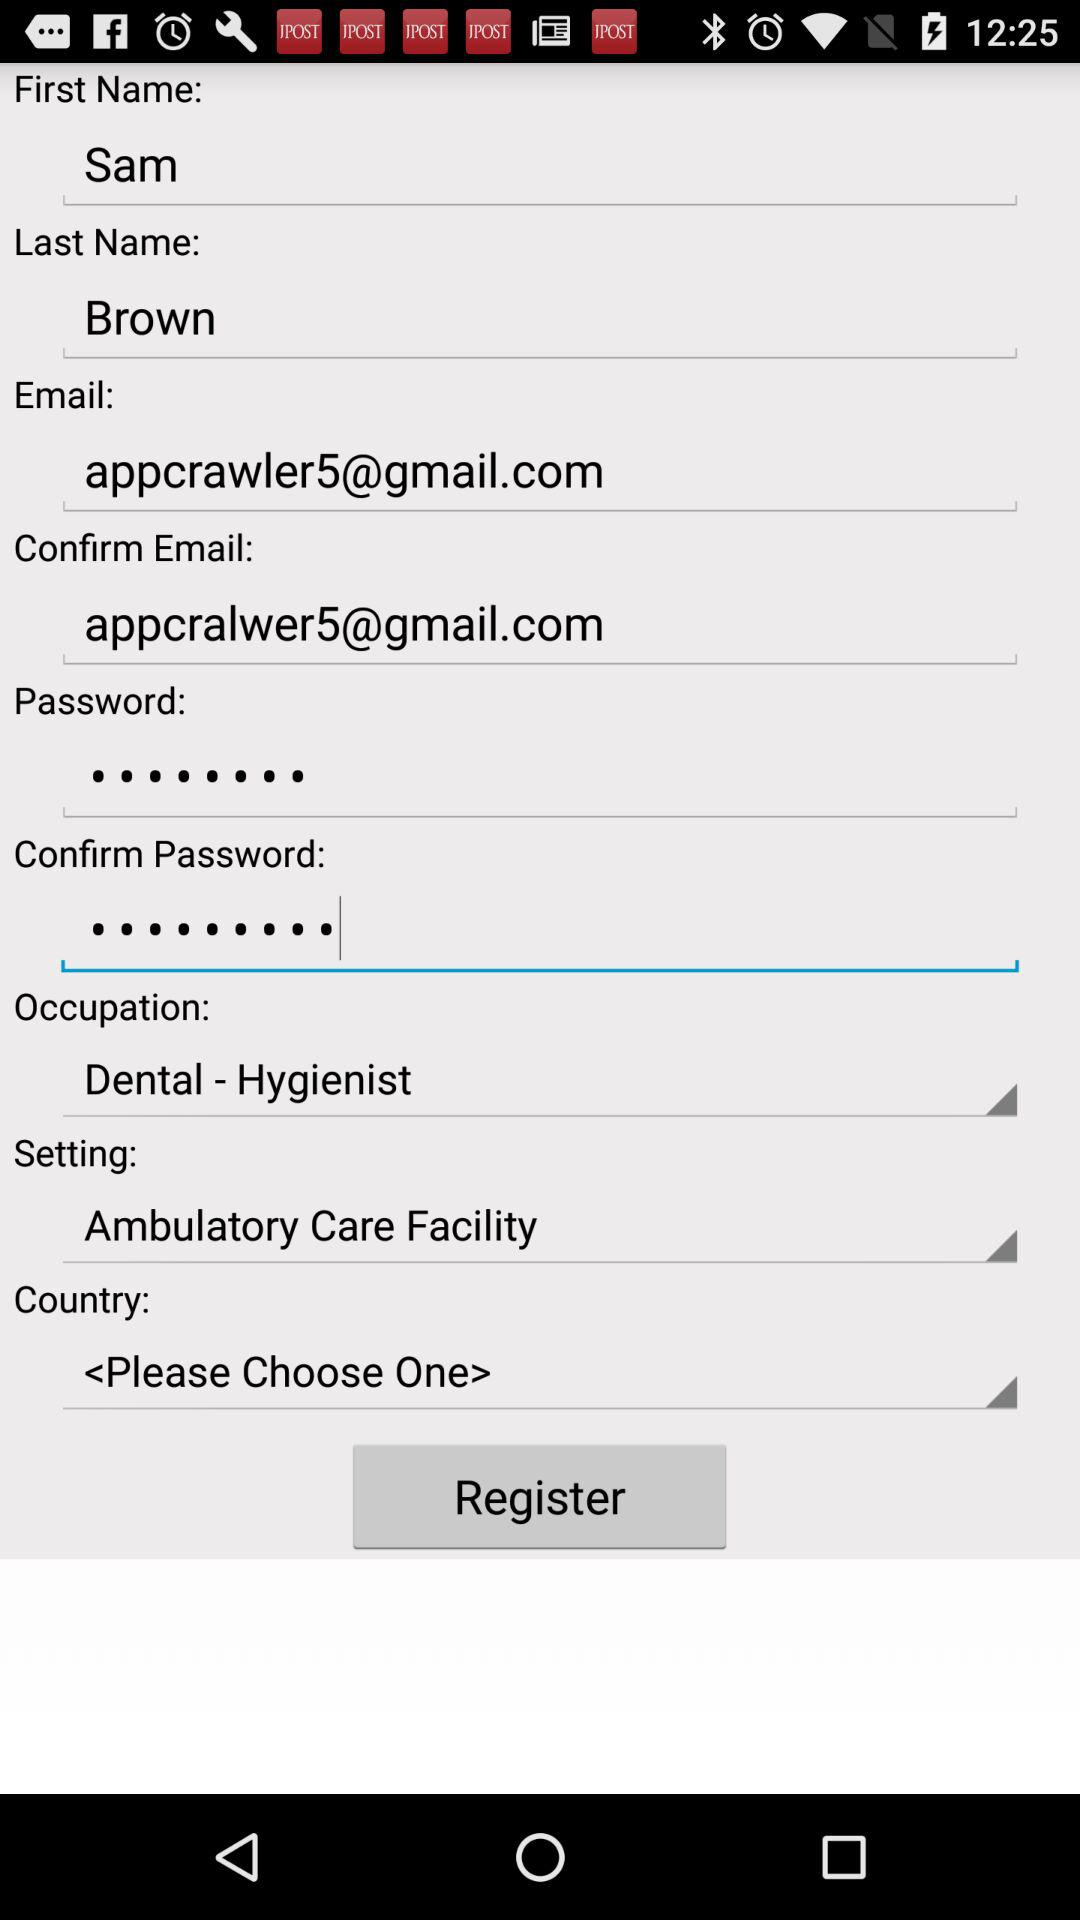What is the occupation? The occupation is dental-hygienist. 